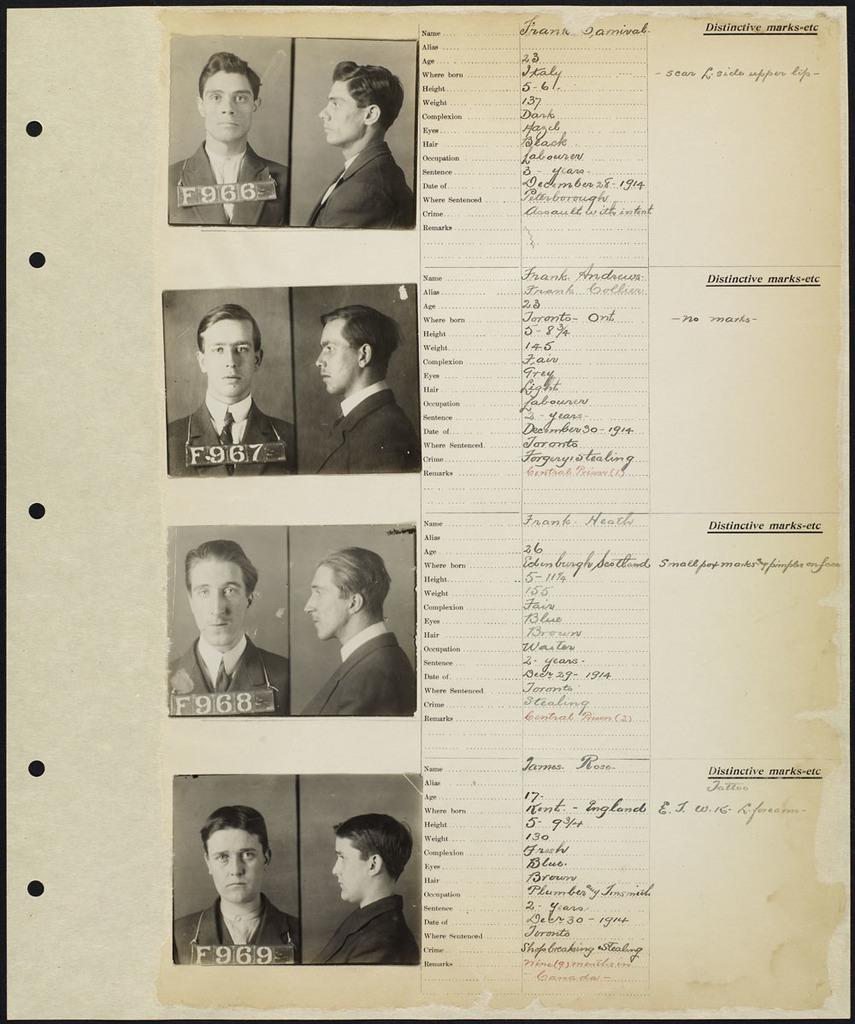What is the color scheme of the image? The image is black and white. What type of content can be seen in the image? There are people's photos, text, and numbers in the image. Can you tell me how many potatoes are in the image? There are no potatoes present in the image. What type of cart is shown in the image? There is no cart present in the image. 